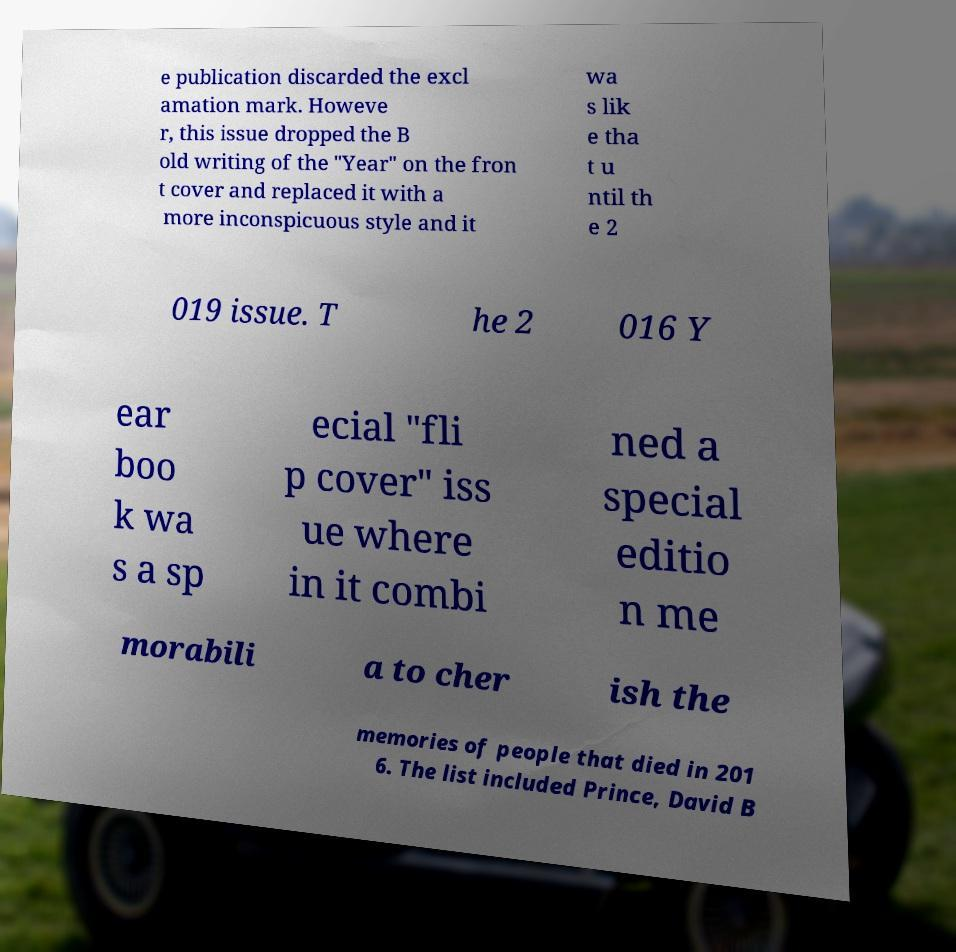For documentation purposes, I need the text within this image transcribed. Could you provide that? e publication discarded the excl amation mark. Howeve r, this issue dropped the B old writing of the "Year" on the fron t cover and replaced it with a more inconspicuous style and it wa s lik e tha t u ntil th e 2 019 issue. T he 2 016 Y ear boo k wa s a sp ecial "fli p cover" iss ue where in it combi ned a special editio n me morabili a to cher ish the memories of people that died in 201 6. The list included Prince, David B 